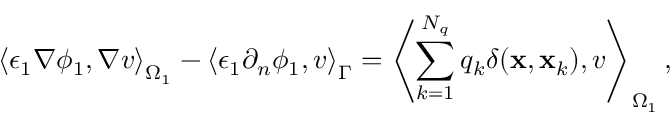<formula> <loc_0><loc_0><loc_500><loc_500>\left \langle \epsilon _ { 1 } \nabla \phi _ { 1 } , \nabla v \right \rangle _ { \Omega _ { 1 } } - \left \langle \epsilon _ { 1 } \partial _ { n } \phi _ { 1 } , v \right \rangle _ { \Gamma } = \left \langle \sum _ { k = 1 } ^ { N _ { q } } q _ { k } \delta ( x , x _ { k } ) , v \right \rangle _ { \Omega _ { 1 } } ,</formula> 